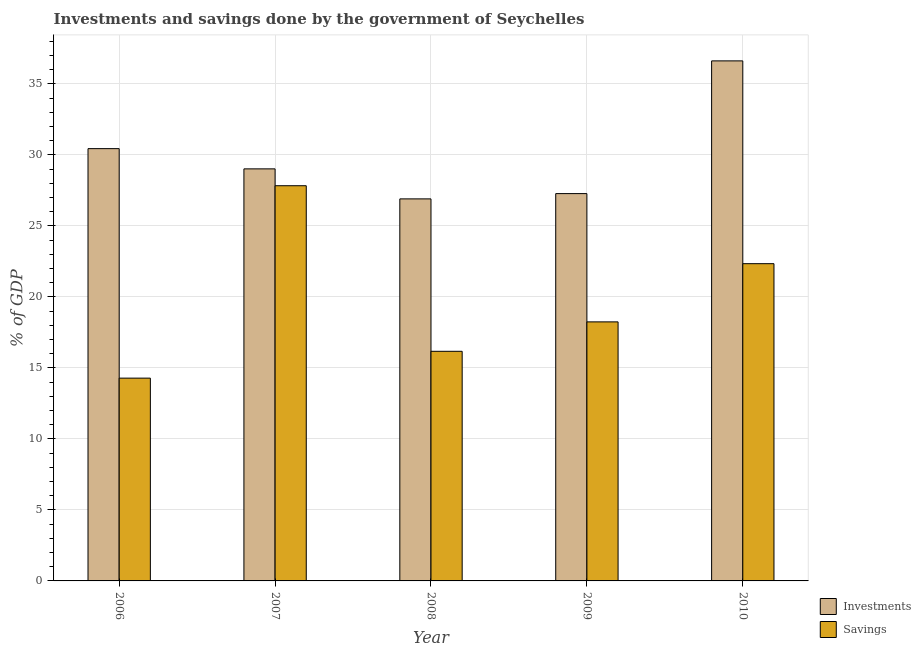How many different coloured bars are there?
Your answer should be compact. 2. How many groups of bars are there?
Offer a terse response. 5. Are the number of bars per tick equal to the number of legend labels?
Offer a very short reply. Yes. Are the number of bars on each tick of the X-axis equal?
Provide a succinct answer. Yes. How many bars are there on the 2nd tick from the left?
Ensure brevity in your answer.  2. What is the investments of government in 2007?
Give a very brief answer. 29.02. Across all years, what is the maximum investments of government?
Your answer should be very brief. 36.62. Across all years, what is the minimum investments of government?
Ensure brevity in your answer.  26.9. In which year was the investments of government maximum?
Provide a short and direct response. 2010. In which year was the investments of government minimum?
Give a very brief answer. 2008. What is the total investments of government in the graph?
Your response must be concise. 150.27. What is the difference between the savings of government in 2007 and that in 2009?
Keep it short and to the point. 9.59. What is the difference between the savings of government in 2008 and the investments of government in 2010?
Make the answer very short. -6.17. What is the average investments of government per year?
Give a very brief answer. 30.05. In the year 2008, what is the difference between the investments of government and savings of government?
Provide a succinct answer. 0. What is the ratio of the savings of government in 2007 to that in 2010?
Ensure brevity in your answer.  1.25. What is the difference between the highest and the second highest savings of government?
Ensure brevity in your answer.  5.49. What is the difference between the highest and the lowest savings of government?
Ensure brevity in your answer.  13.55. In how many years, is the investments of government greater than the average investments of government taken over all years?
Provide a short and direct response. 2. Is the sum of the savings of government in 2006 and 2010 greater than the maximum investments of government across all years?
Your response must be concise. Yes. What does the 2nd bar from the left in 2006 represents?
Ensure brevity in your answer.  Savings. What does the 2nd bar from the right in 2010 represents?
Make the answer very short. Investments. What is the difference between two consecutive major ticks on the Y-axis?
Make the answer very short. 5. How many legend labels are there?
Ensure brevity in your answer.  2. What is the title of the graph?
Offer a very short reply. Investments and savings done by the government of Seychelles. What is the label or title of the Y-axis?
Give a very brief answer. % of GDP. What is the % of GDP of Investments in 2006?
Make the answer very short. 30.44. What is the % of GDP of Savings in 2006?
Provide a succinct answer. 14.28. What is the % of GDP of Investments in 2007?
Your answer should be very brief. 29.02. What is the % of GDP in Savings in 2007?
Your answer should be compact. 27.83. What is the % of GDP of Investments in 2008?
Keep it short and to the point. 26.9. What is the % of GDP of Savings in 2008?
Offer a very short reply. 16.17. What is the % of GDP in Investments in 2009?
Make the answer very short. 27.28. What is the % of GDP in Savings in 2009?
Make the answer very short. 18.24. What is the % of GDP in Investments in 2010?
Provide a succinct answer. 36.62. What is the % of GDP of Savings in 2010?
Provide a succinct answer. 22.34. Across all years, what is the maximum % of GDP in Investments?
Offer a terse response. 36.62. Across all years, what is the maximum % of GDP of Savings?
Your response must be concise. 27.83. Across all years, what is the minimum % of GDP in Investments?
Give a very brief answer. 26.9. Across all years, what is the minimum % of GDP in Savings?
Your response must be concise. 14.28. What is the total % of GDP of Investments in the graph?
Offer a very short reply. 150.27. What is the total % of GDP of Savings in the graph?
Provide a short and direct response. 98.87. What is the difference between the % of GDP of Investments in 2006 and that in 2007?
Provide a short and direct response. 1.42. What is the difference between the % of GDP of Savings in 2006 and that in 2007?
Offer a very short reply. -13.55. What is the difference between the % of GDP of Investments in 2006 and that in 2008?
Keep it short and to the point. 3.54. What is the difference between the % of GDP of Savings in 2006 and that in 2008?
Offer a very short reply. -1.89. What is the difference between the % of GDP of Investments in 2006 and that in 2009?
Provide a succinct answer. 3.17. What is the difference between the % of GDP of Savings in 2006 and that in 2009?
Your answer should be very brief. -3.96. What is the difference between the % of GDP of Investments in 2006 and that in 2010?
Provide a succinct answer. -6.18. What is the difference between the % of GDP in Savings in 2006 and that in 2010?
Offer a terse response. -8.06. What is the difference between the % of GDP in Investments in 2007 and that in 2008?
Make the answer very short. 2.11. What is the difference between the % of GDP in Savings in 2007 and that in 2008?
Give a very brief answer. 11.66. What is the difference between the % of GDP of Investments in 2007 and that in 2009?
Your answer should be compact. 1.74. What is the difference between the % of GDP of Savings in 2007 and that in 2009?
Offer a very short reply. 9.59. What is the difference between the % of GDP of Investments in 2007 and that in 2010?
Your answer should be very brief. -7.6. What is the difference between the % of GDP of Savings in 2007 and that in 2010?
Provide a succinct answer. 5.49. What is the difference between the % of GDP in Investments in 2008 and that in 2009?
Keep it short and to the point. -0.37. What is the difference between the % of GDP in Savings in 2008 and that in 2009?
Your answer should be very brief. -2.07. What is the difference between the % of GDP in Investments in 2008 and that in 2010?
Provide a short and direct response. -9.72. What is the difference between the % of GDP of Savings in 2008 and that in 2010?
Provide a succinct answer. -6.17. What is the difference between the % of GDP of Investments in 2009 and that in 2010?
Your answer should be very brief. -9.35. What is the difference between the % of GDP of Savings in 2009 and that in 2010?
Your response must be concise. -4.1. What is the difference between the % of GDP in Investments in 2006 and the % of GDP in Savings in 2007?
Provide a short and direct response. 2.61. What is the difference between the % of GDP of Investments in 2006 and the % of GDP of Savings in 2008?
Offer a very short reply. 14.27. What is the difference between the % of GDP in Investments in 2006 and the % of GDP in Savings in 2009?
Provide a succinct answer. 12.2. What is the difference between the % of GDP of Investments in 2006 and the % of GDP of Savings in 2010?
Provide a short and direct response. 8.1. What is the difference between the % of GDP of Investments in 2007 and the % of GDP of Savings in 2008?
Make the answer very short. 12.85. What is the difference between the % of GDP in Investments in 2007 and the % of GDP in Savings in 2009?
Your answer should be compact. 10.78. What is the difference between the % of GDP of Investments in 2007 and the % of GDP of Savings in 2010?
Provide a succinct answer. 6.68. What is the difference between the % of GDP of Investments in 2008 and the % of GDP of Savings in 2009?
Make the answer very short. 8.66. What is the difference between the % of GDP in Investments in 2008 and the % of GDP in Savings in 2010?
Your answer should be very brief. 4.56. What is the difference between the % of GDP in Investments in 2009 and the % of GDP in Savings in 2010?
Make the answer very short. 4.94. What is the average % of GDP of Investments per year?
Provide a short and direct response. 30.05. What is the average % of GDP of Savings per year?
Provide a succinct answer. 19.77. In the year 2006, what is the difference between the % of GDP of Investments and % of GDP of Savings?
Keep it short and to the point. 16.16. In the year 2007, what is the difference between the % of GDP in Investments and % of GDP in Savings?
Your answer should be very brief. 1.19. In the year 2008, what is the difference between the % of GDP in Investments and % of GDP in Savings?
Offer a very short reply. 10.73. In the year 2009, what is the difference between the % of GDP of Investments and % of GDP of Savings?
Ensure brevity in your answer.  9.03. In the year 2010, what is the difference between the % of GDP of Investments and % of GDP of Savings?
Make the answer very short. 14.28. What is the ratio of the % of GDP in Investments in 2006 to that in 2007?
Make the answer very short. 1.05. What is the ratio of the % of GDP of Savings in 2006 to that in 2007?
Offer a terse response. 0.51. What is the ratio of the % of GDP in Investments in 2006 to that in 2008?
Provide a short and direct response. 1.13. What is the ratio of the % of GDP of Savings in 2006 to that in 2008?
Give a very brief answer. 0.88. What is the ratio of the % of GDP in Investments in 2006 to that in 2009?
Offer a very short reply. 1.12. What is the ratio of the % of GDP in Savings in 2006 to that in 2009?
Make the answer very short. 0.78. What is the ratio of the % of GDP of Investments in 2006 to that in 2010?
Provide a succinct answer. 0.83. What is the ratio of the % of GDP in Savings in 2006 to that in 2010?
Ensure brevity in your answer.  0.64. What is the ratio of the % of GDP in Investments in 2007 to that in 2008?
Your answer should be compact. 1.08. What is the ratio of the % of GDP of Savings in 2007 to that in 2008?
Your response must be concise. 1.72. What is the ratio of the % of GDP in Investments in 2007 to that in 2009?
Provide a short and direct response. 1.06. What is the ratio of the % of GDP in Savings in 2007 to that in 2009?
Your response must be concise. 1.53. What is the ratio of the % of GDP in Investments in 2007 to that in 2010?
Provide a short and direct response. 0.79. What is the ratio of the % of GDP of Savings in 2007 to that in 2010?
Offer a very short reply. 1.25. What is the ratio of the % of GDP in Investments in 2008 to that in 2009?
Provide a short and direct response. 0.99. What is the ratio of the % of GDP of Savings in 2008 to that in 2009?
Give a very brief answer. 0.89. What is the ratio of the % of GDP of Investments in 2008 to that in 2010?
Offer a terse response. 0.73. What is the ratio of the % of GDP of Savings in 2008 to that in 2010?
Your answer should be compact. 0.72. What is the ratio of the % of GDP of Investments in 2009 to that in 2010?
Your answer should be very brief. 0.74. What is the ratio of the % of GDP in Savings in 2009 to that in 2010?
Ensure brevity in your answer.  0.82. What is the difference between the highest and the second highest % of GDP in Investments?
Make the answer very short. 6.18. What is the difference between the highest and the second highest % of GDP in Savings?
Offer a terse response. 5.49. What is the difference between the highest and the lowest % of GDP in Investments?
Make the answer very short. 9.72. What is the difference between the highest and the lowest % of GDP of Savings?
Provide a succinct answer. 13.55. 